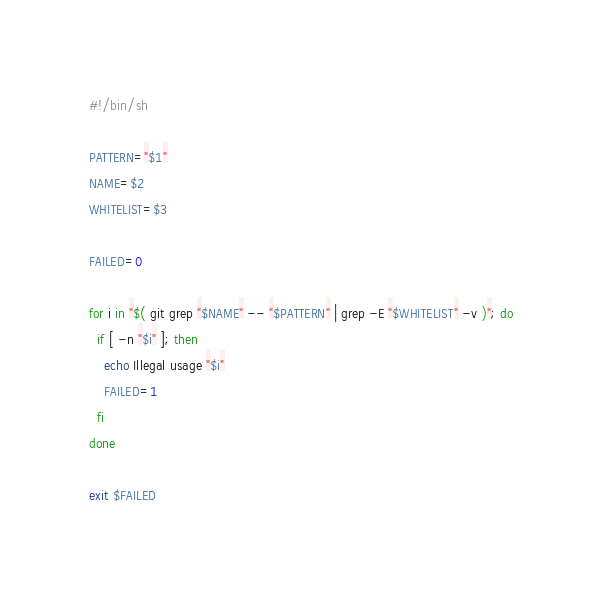<code> <loc_0><loc_0><loc_500><loc_500><_Bash_>#!/bin/sh

PATTERN="$1"
NAME=$2
WHITELIST=$3

FAILED=0

for i in "$( git grep "$NAME" -- "$PATTERN" | grep -E "$WHITELIST" -v )"; do
  if [ -n "$i" ]; then
    echo Illegal usage "$i"
    FAILED=1
  fi
done

exit $FAILED</code> 